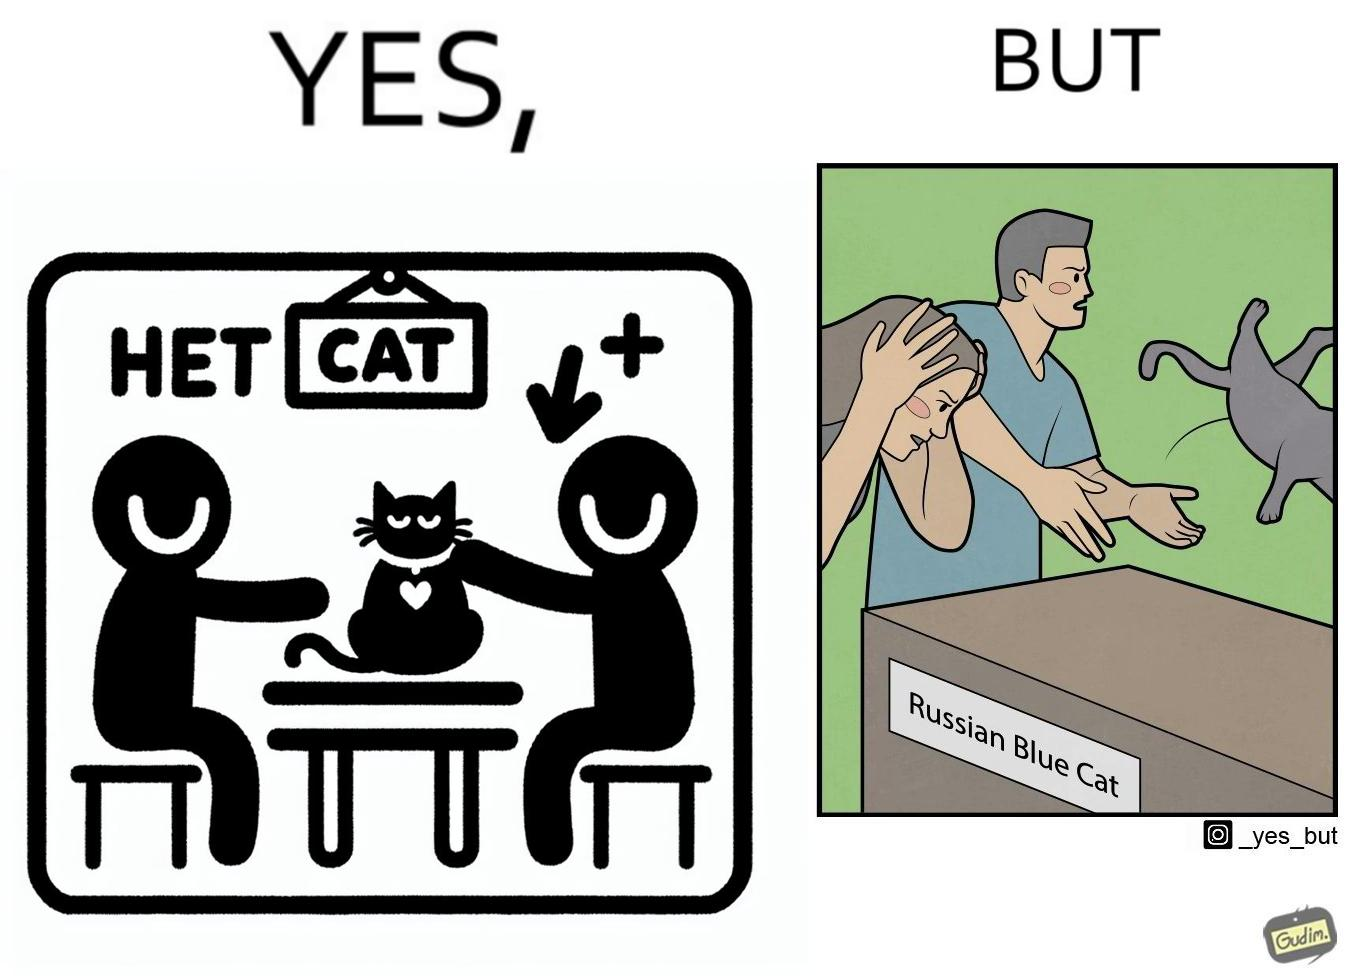Describe the satirical element in this image. The image is confusing, as initially, when the label reads "Blue Cat", the people are happy and are petting tha cat, but as soon as one of them realizes that the entire text reads "Russian Blue Cat", they seem to worried, and one of them throws away the cat. For some reason, the word "Russian" is a trigger word for them. 